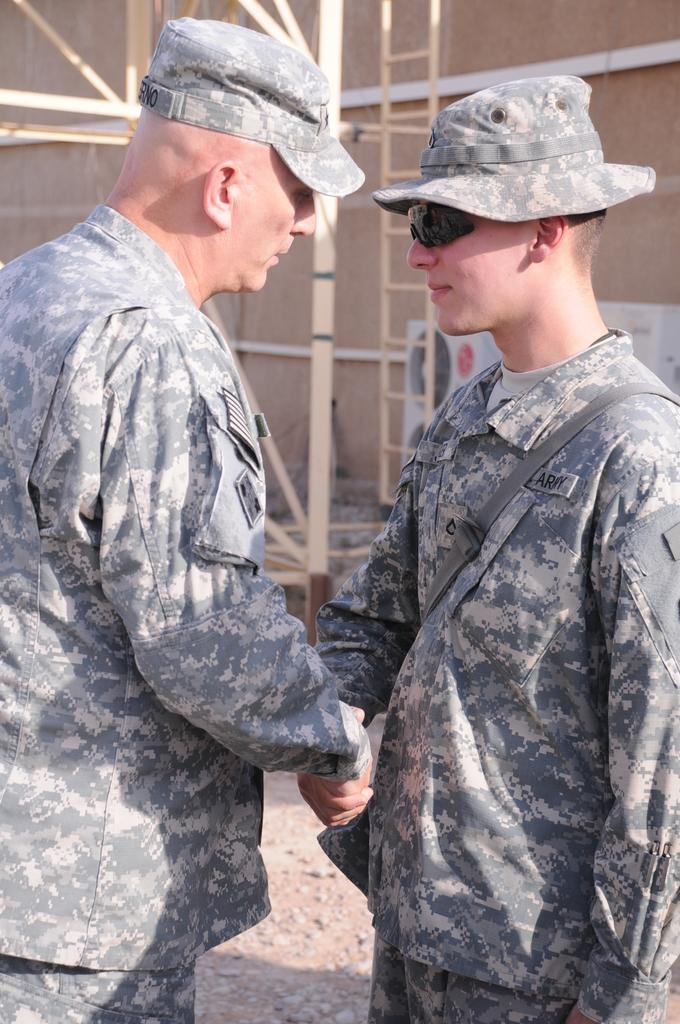How many people are in the image? There are two people in the image. What are the two people doing? The two people are shaking hands. Can you describe one of the people in the image? One of the people is carrying a bag. What can be seen in the background of the image? There is an electrical object, a wooden wall, a ladder, and wooden sticks in the background of the image. What type of design advice can be seen on the wooden sticks in the image? There is no design advice present on the wooden sticks in the image. Is there any smoke visible in the image? There is no smoke visible in the image. 